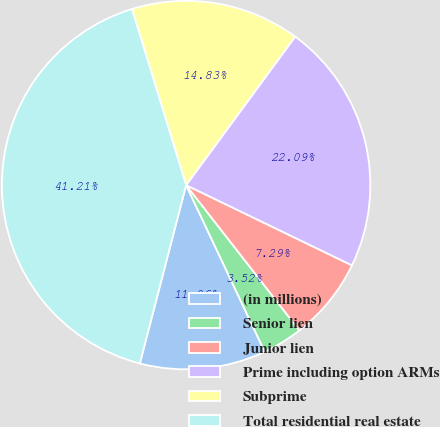Convert chart. <chart><loc_0><loc_0><loc_500><loc_500><pie_chart><fcel>(in millions)<fcel>Senior lien<fcel>Junior lien<fcel>Prime including option ARMs<fcel>Subprime<fcel>Total residential real estate<nl><fcel>11.06%<fcel>3.52%<fcel>7.29%<fcel>22.09%<fcel>14.83%<fcel>41.21%<nl></chart> 